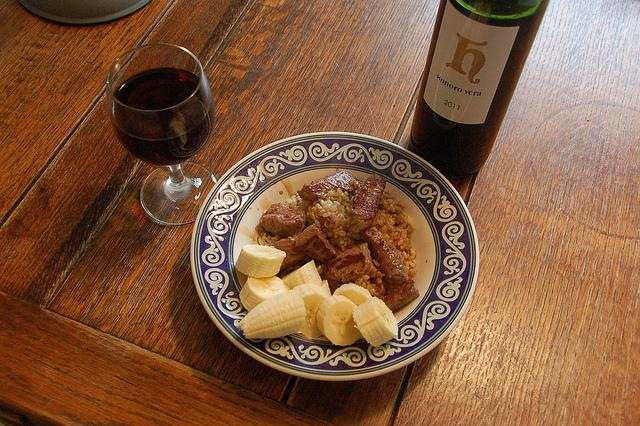Which item contains a lot of potassium? banana 